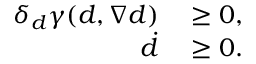<formula> <loc_0><loc_0><loc_500><loc_500>\begin{array} { r l } { \delta _ { d } \gamma ( d , \nabla d ) } & \geq 0 , } \\ { \dot { d } } & \geq 0 . } \end{array}</formula> 